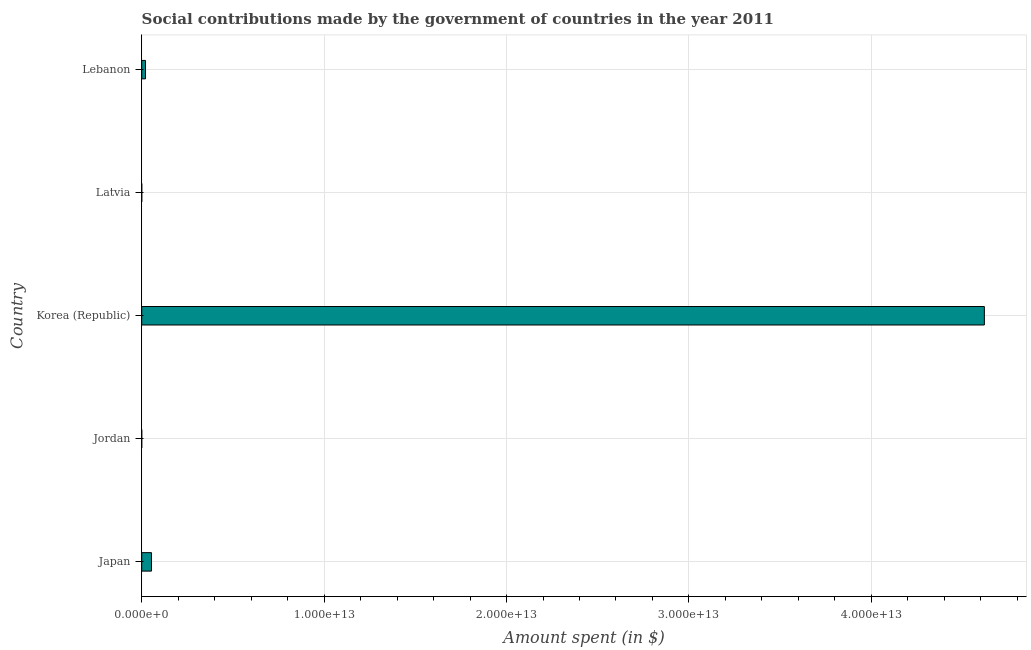Does the graph contain grids?
Offer a terse response. Yes. What is the title of the graph?
Keep it short and to the point. Social contributions made by the government of countries in the year 2011. What is the label or title of the X-axis?
Your response must be concise. Amount spent (in $). What is the label or title of the Y-axis?
Provide a short and direct response. Country. What is the amount spent in making social contributions in Lebanon?
Provide a succinct answer. 2.06e+11. Across all countries, what is the maximum amount spent in making social contributions?
Your response must be concise. 4.62e+13. Across all countries, what is the minimum amount spent in making social contributions?
Offer a terse response. 2.07e+07. In which country was the amount spent in making social contributions maximum?
Your response must be concise. Korea (Republic). In which country was the amount spent in making social contributions minimum?
Offer a terse response. Jordan. What is the sum of the amount spent in making social contributions?
Provide a short and direct response. 4.69e+13. What is the difference between the amount spent in making social contributions in Latvia and Lebanon?
Your response must be concise. -2.05e+11. What is the average amount spent in making social contributions per country?
Keep it short and to the point. 9.39e+12. What is the median amount spent in making social contributions?
Keep it short and to the point. 2.06e+11. What is the ratio of the amount spent in making social contributions in Japan to that in Korea (Republic)?
Ensure brevity in your answer.  0.01. Is the amount spent in making social contributions in Japan less than that in Latvia?
Make the answer very short. No. Is the difference between the amount spent in making social contributions in Jordan and Lebanon greater than the difference between any two countries?
Provide a succinct answer. No. What is the difference between the highest and the second highest amount spent in making social contributions?
Your answer should be compact. 4.57e+13. Is the sum of the amount spent in making social contributions in Japan and Jordan greater than the maximum amount spent in making social contributions across all countries?
Offer a terse response. No. What is the difference between the highest and the lowest amount spent in making social contributions?
Provide a succinct answer. 4.62e+13. In how many countries, is the amount spent in making social contributions greater than the average amount spent in making social contributions taken over all countries?
Keep it short and to the point. 1. How many bars are there?
Offer a very short reply. 5. How many countries are there in the graph?
Your response must be concise. 5. What is the difference between two consecutive major ticks on the X-axis?
Provide a succinct answer. 1.00e+13. What is the Amount spent (in $) in Japan?
Keep it short and to the point. 5.35e+11. What is the Amount spent (in $) in Jordan?
Keep it short and to the point. 2.07e+07. What is the Amount spent (in $) of Korea (Republic)?
Your response must be concise. 4.62e+13. What is the Amount spent (in $) in Latvia?
Provide a short and direct response. 1.23e+09. What is the Amount spent (in $) in Lebanon?
Give a very brief answer. 2.06e+11. What is the difference between the Amount spent (in $) in Japan and Jordan?
Give a very brief answer. 5.35e+11. What is the difference between the Amount spent (in $) in Japan and Korea (Republic)?
Provide a short and direct response. -4.57e+13. What is the difference between the Amount spent (in $) in Japan and Latvia?
Offer a terse response. 5.34e+11. What is the difference between the Amount spent (in $) in Japan and Lebanon?
Ensure brevity in your answer.  3.29e+11. What is the difference between the Amount spent (in $) in Jordan and Korea (Republic)?
Make the answer very short. -4.62e+13. What is the difference between the Amount spent (in $) in Jordan and Latvia?
Provide a short and direct response. -1.21e+09. What is the difference between the Amount spent (in $) in Jordan and Lebanon?
Offer a very short reply. -2.06e+11. What is the difference between the Amount spent (in $) in Korea (Republic) and Latvia?
Your response must be concise. 4.62e+13. What is the difference between the Amount spent (in $) in Korea (Republic) and Lebanon?
Offer a terse response. 4.60e+13. What is the difference between the Amount spent (in $) in Latvia and Lebanon?
Make the answer very short. -2.05e+11. What is the ratio of the Amount spent (in $) in Japan to that in Jordan?
Offer a terse response. 2.59e+04. What is the ratio of the Amount spent (in $) in Japan to that in Korea (Republic)?
Keep it short and to the point. 0.01. What is the ratio of the Amount spent (in $) in Japan to that in Latvia?
Your answer should be very brief. 435.43. What is the ratio of the Amount spent (in $) in Japan to that in Lebanon?
Offer a very short reply. 2.59. What is the ratio of the Amount spent (in $) in Jordan to that in Latvia?
Offer a terse response. 0.02. What is the ratio of the Amount spent (in $) in Jordan to that in Lebanon?
Provide a succinct answer. 0. What is the ratio of the Amount spent (in $) in Korea (Republic) to that in Latvia?
Offer a very short reply. 3.76e+04. What is the ratio of the Amount spent (in $) in Korea (Republic) to that in Lebanon?
Your answer should be compact. 223.81. What is the ratio of the Amount spent (in $) in Latvia to that in Lebanon?
Provide a short and direct response. 0.01. 